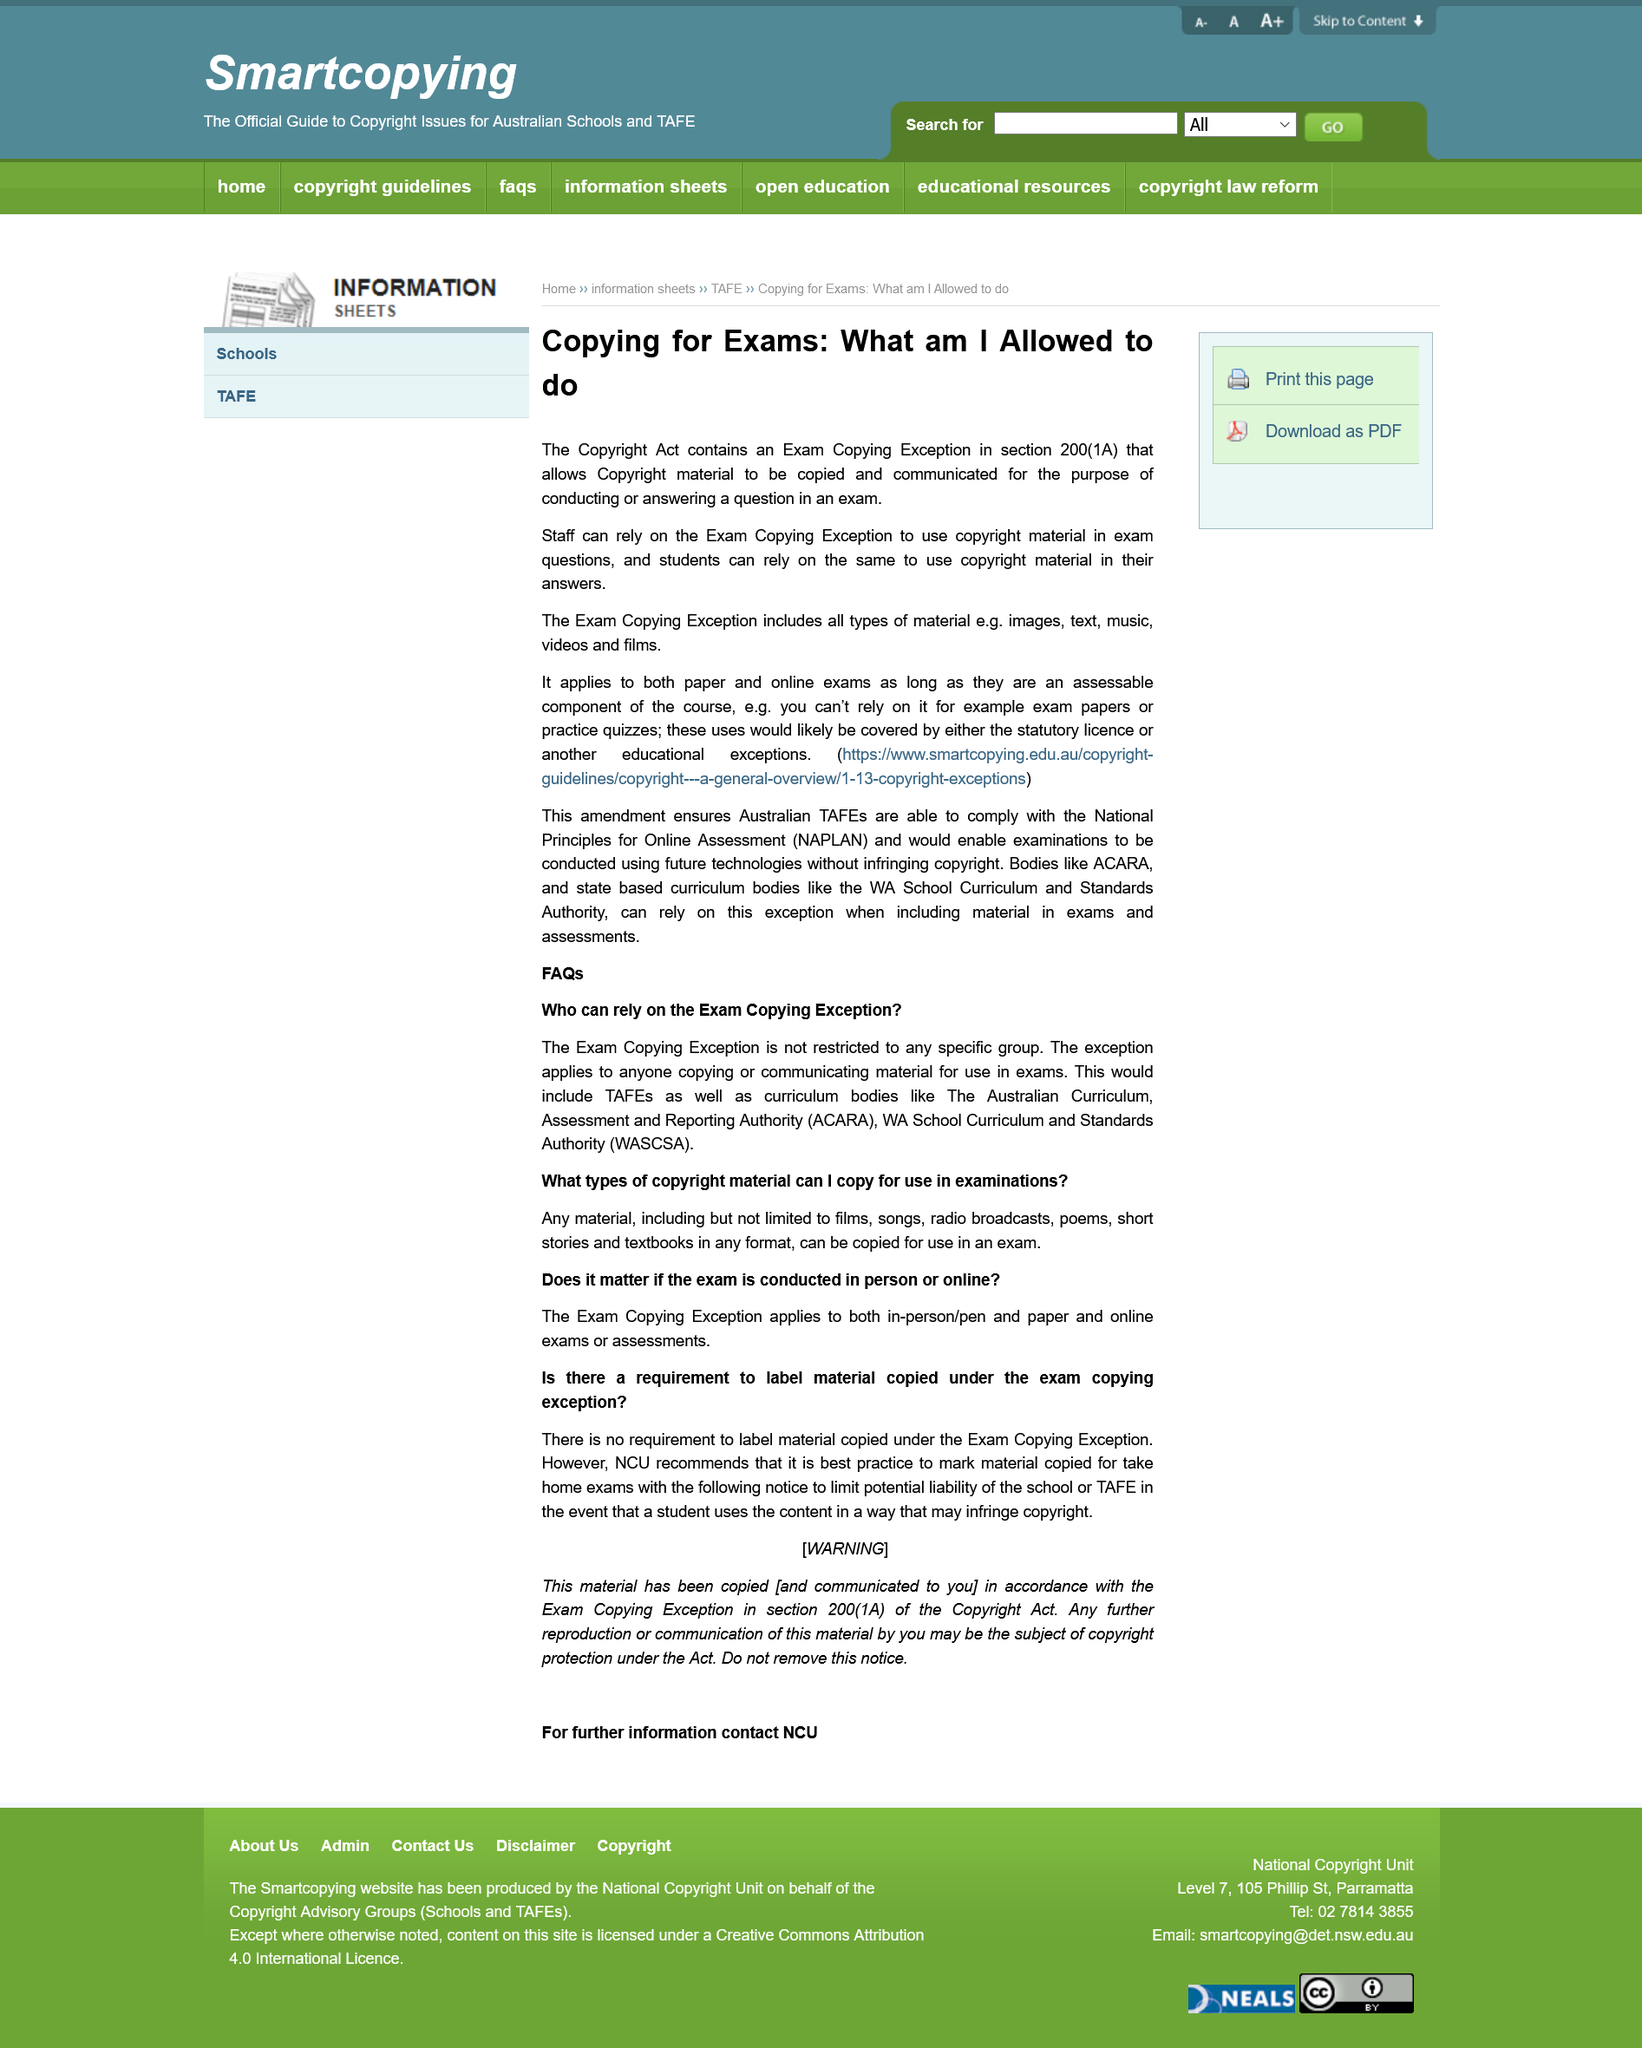Give some essential details in this illustration. The Copyright Act contains an Exam Copying Exception in section 200(1A) of the act. The Exam Copying Exception applies to video material used in online exams, as long as they are an assessable component of the course. The Exam Copying Exception can be relied upon by anyone who is copying or communicating material for use in exams, including TAFEs and curriculum bodies. The Exam Copying Exception is not restricted to any specific group. The Exam Copying Exception does not apply to example exam papers or practice quizzes. 